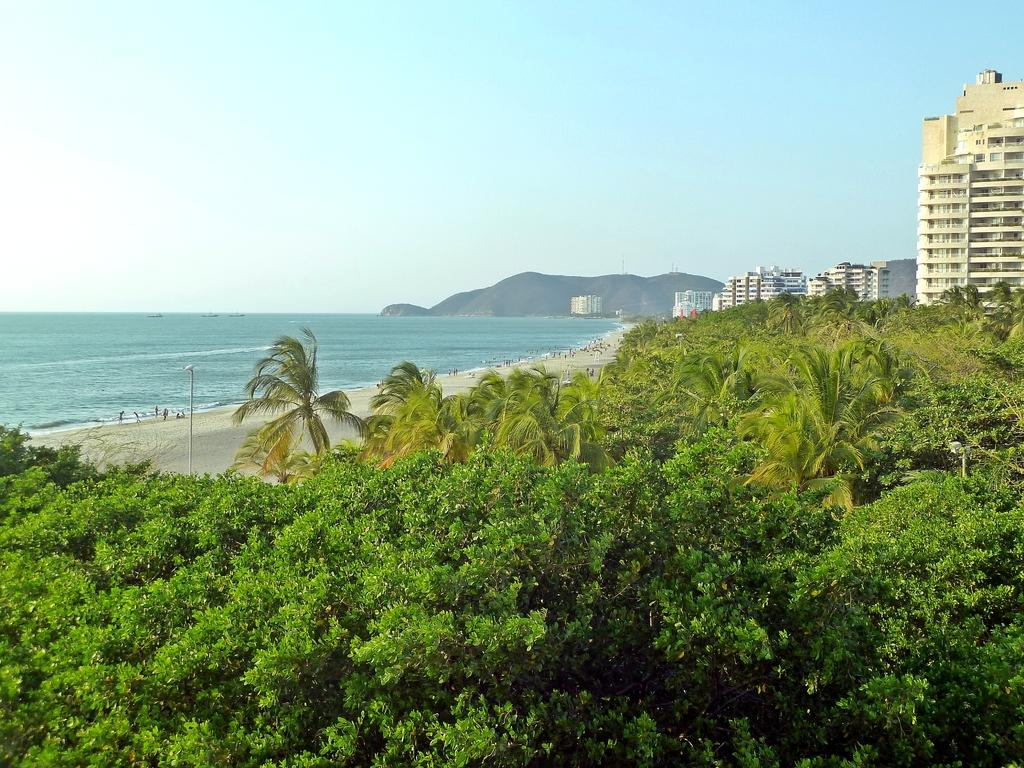What type of vegetation can be seen in the image? There are trees in the image. What is the color of the trees? The trees are green. What can be seen in the background of the image? There is water, people, buildings, and mountains visible in the background. What is the color of the sky in the image? The sky is blue and white. How many buttons can be seen on the trees in the image? There are no buttons present on the trees in the image. What type of bikes are being ridden by the people in the image? There are no bikes visible in the image; only people, buildings, and mountains can be seen in the background. 